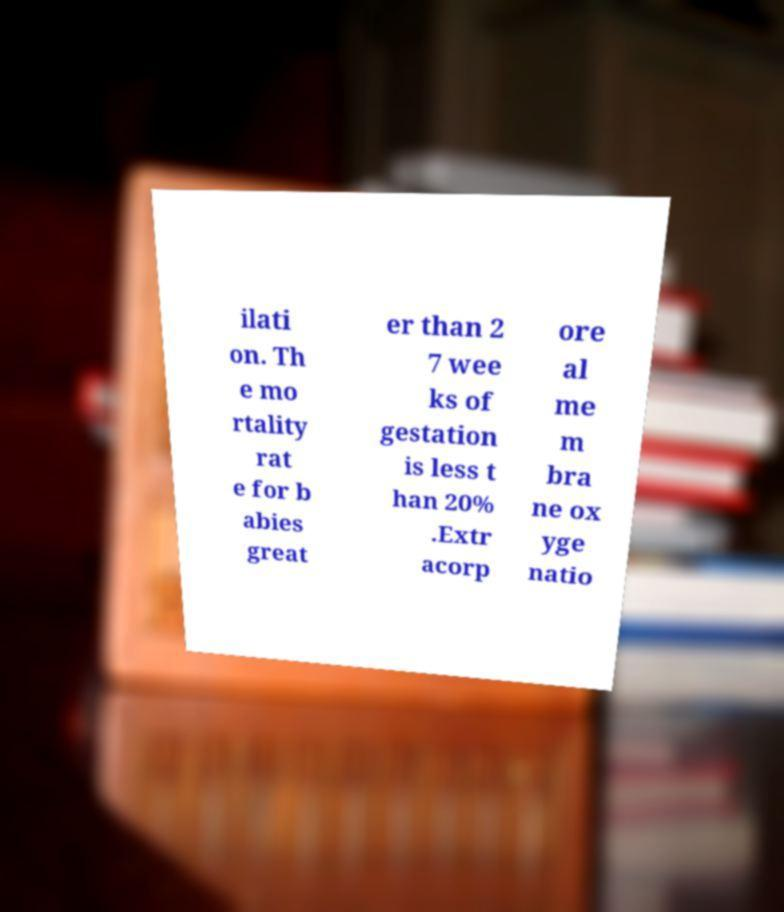Please read and relay the text visible in this image. What does it say? ilati on. Th e mo rtality rat e for b abies great er than 2 7 wee ks of gestation is less t han 20% .Extr acorp ore al me m bra ne ox yge natio 